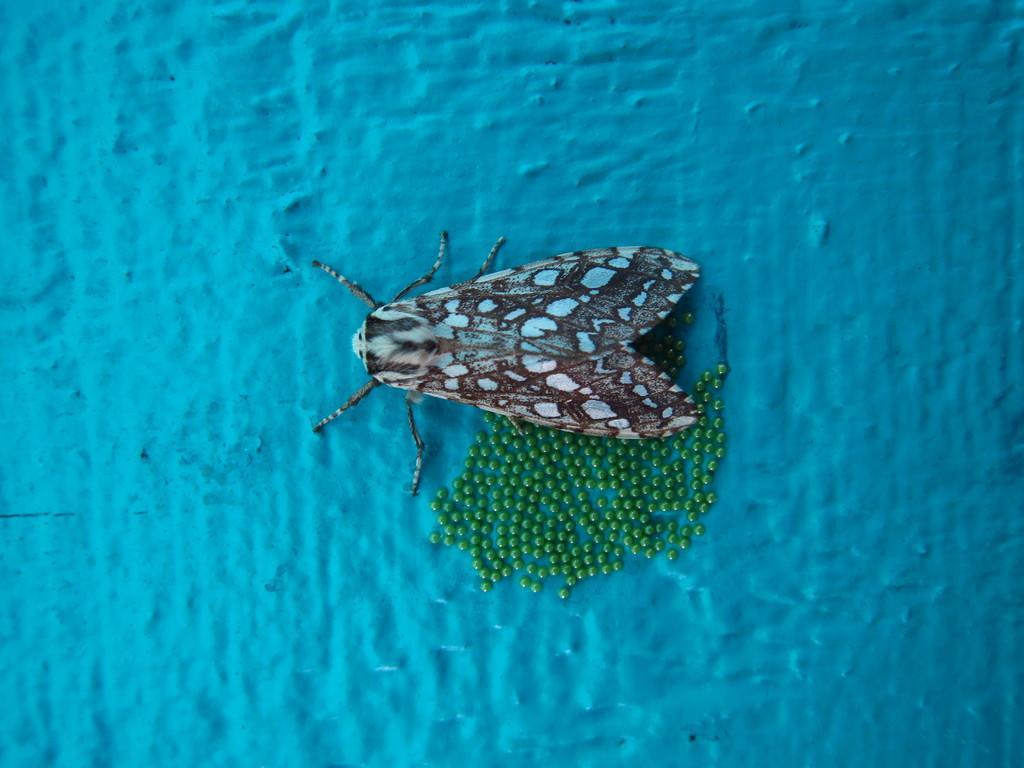Could you give a brief overview of what you see in this image? In the middle of this image, there is an insect, on which there are green color eggs. And the background is blue in color. 